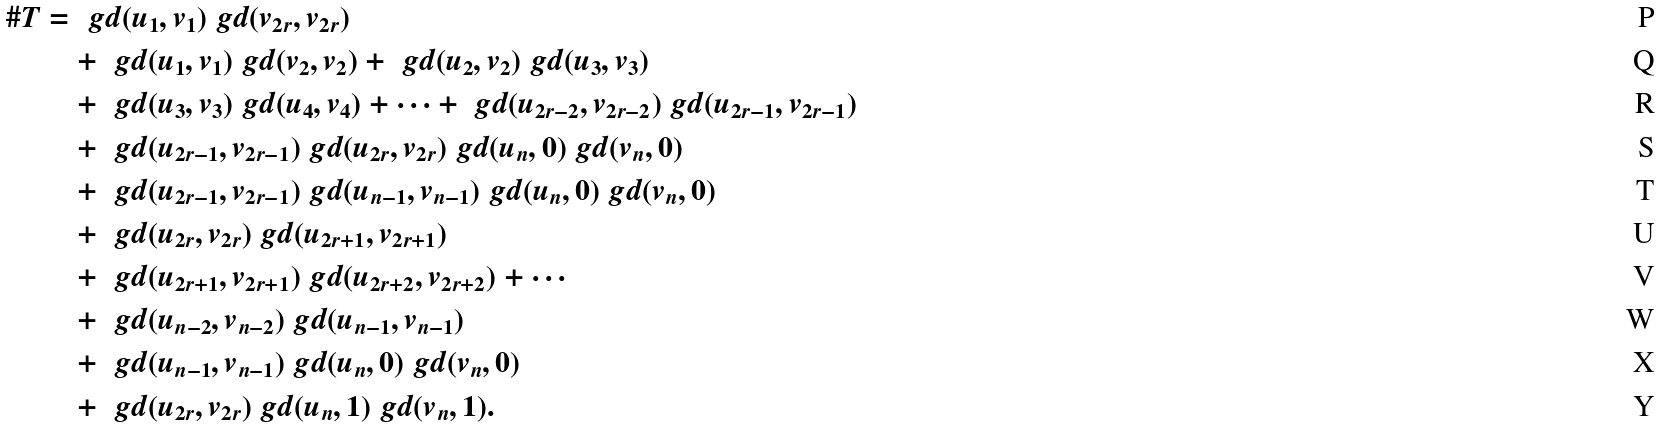<formula> <loc_0><loc_0><loc_500><loc_500>\# T & = \ g d ( u _ { 1 } , v _ { 1 } ) \ g d ( v _ { 2 r } , v _ { 2 r } ) \\ & \quad + \ g d ( u _ { 1 } , v _ { 1 } ) \ g d ( v _ { 2 } , v _ { 2 } ) + \ g d ( u _ { 2 } , v _ { 2 } ) \ g d ( u _ { 3 } , v _ { 3 } ) \\ & \quad + \ g d ( u _ { 3 } , v _ { 3 } ) \ g d ( u _ { 4 } , v _ { 4 } ) + \dots + \ g d ( u _ { 2 r - 2 } , v _ { 2 r - 2 } ) \ g d ( u _ { 2 r - 1 } , v _ { 2 r - 1 } ) \\ & \quad + \ g d ( u _ { 2 r - 1 } , v _ { 2 r - 1 } ) \ g d ( u _ { 2 r } , v _ { 2 r } ) \ g d ( u _ { n } , 0 ) \ g d ( v _ { n } , 0 ) \\ & \quad + \ g d ( u _ { 2 r - 1 } , v _ { 2 r - 1 } ) \ g d ( u _ { n - 1 } , v _ { n - 1 } ) \ g d ( u _ { n } , 0 ) \ g d ( v _ { n } , 0 ) \\ & \quad + \ g d ( u _ { 2 r } , v _ { 2 r } ) \ g d ( u _ { 2 r + 1 } , v _ { 2 r + 1 } ) \\ & \quad + \ g d ( u _ { 2 r + 1 } , v _ { 2 r + 1 } ) \ g d ( u _ { 2 r + 2 } , v _ { 2 r + 2 } ) + \cdots \\ & \quad + \ g d ( u _ { n - 2 } , v _ { n - 2 } ) \ g d ( u _ { n - 1 } , v _ { n - 1 } ) \\ & \quad + \ g d ( u _ { n - 1 } , v _ { n - 1 } ) \ g d ( u _ { n } , 0 ) \ g d ( v _ { n } , 0 ) \\ & \quad + \ g d ( u _ { 2 r } , v _ { 2 r } ) \ g d ( u _ { n } , 1 ) \ g d ( v _ { n } , 1 ) .</formula> 